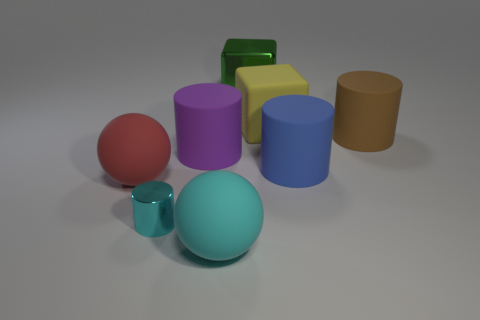Subtract all big purple cylinders. How many cylinders are left? 3 Subtract 2 cylinders. How many cylinders are left? 2 Add 1 small purple metal cylinders. How many objects exist? 9 Subtract all cyan cylinders. How many cylinders are left? 3 Subtract all red cylinders. Subtract all purple balls. How many cylinders are left? 4 Add 8 big blue rubber cylinders. How many big blue rubber cylinders are left? 9 Add 4 purple cylinders. How many purple cylinders exist? 5 Subtract 0 brown cubes. How many objects are left? 8 Subtract all green shiny cubes. Subtract all big blue objects. How many objects are left? 6 